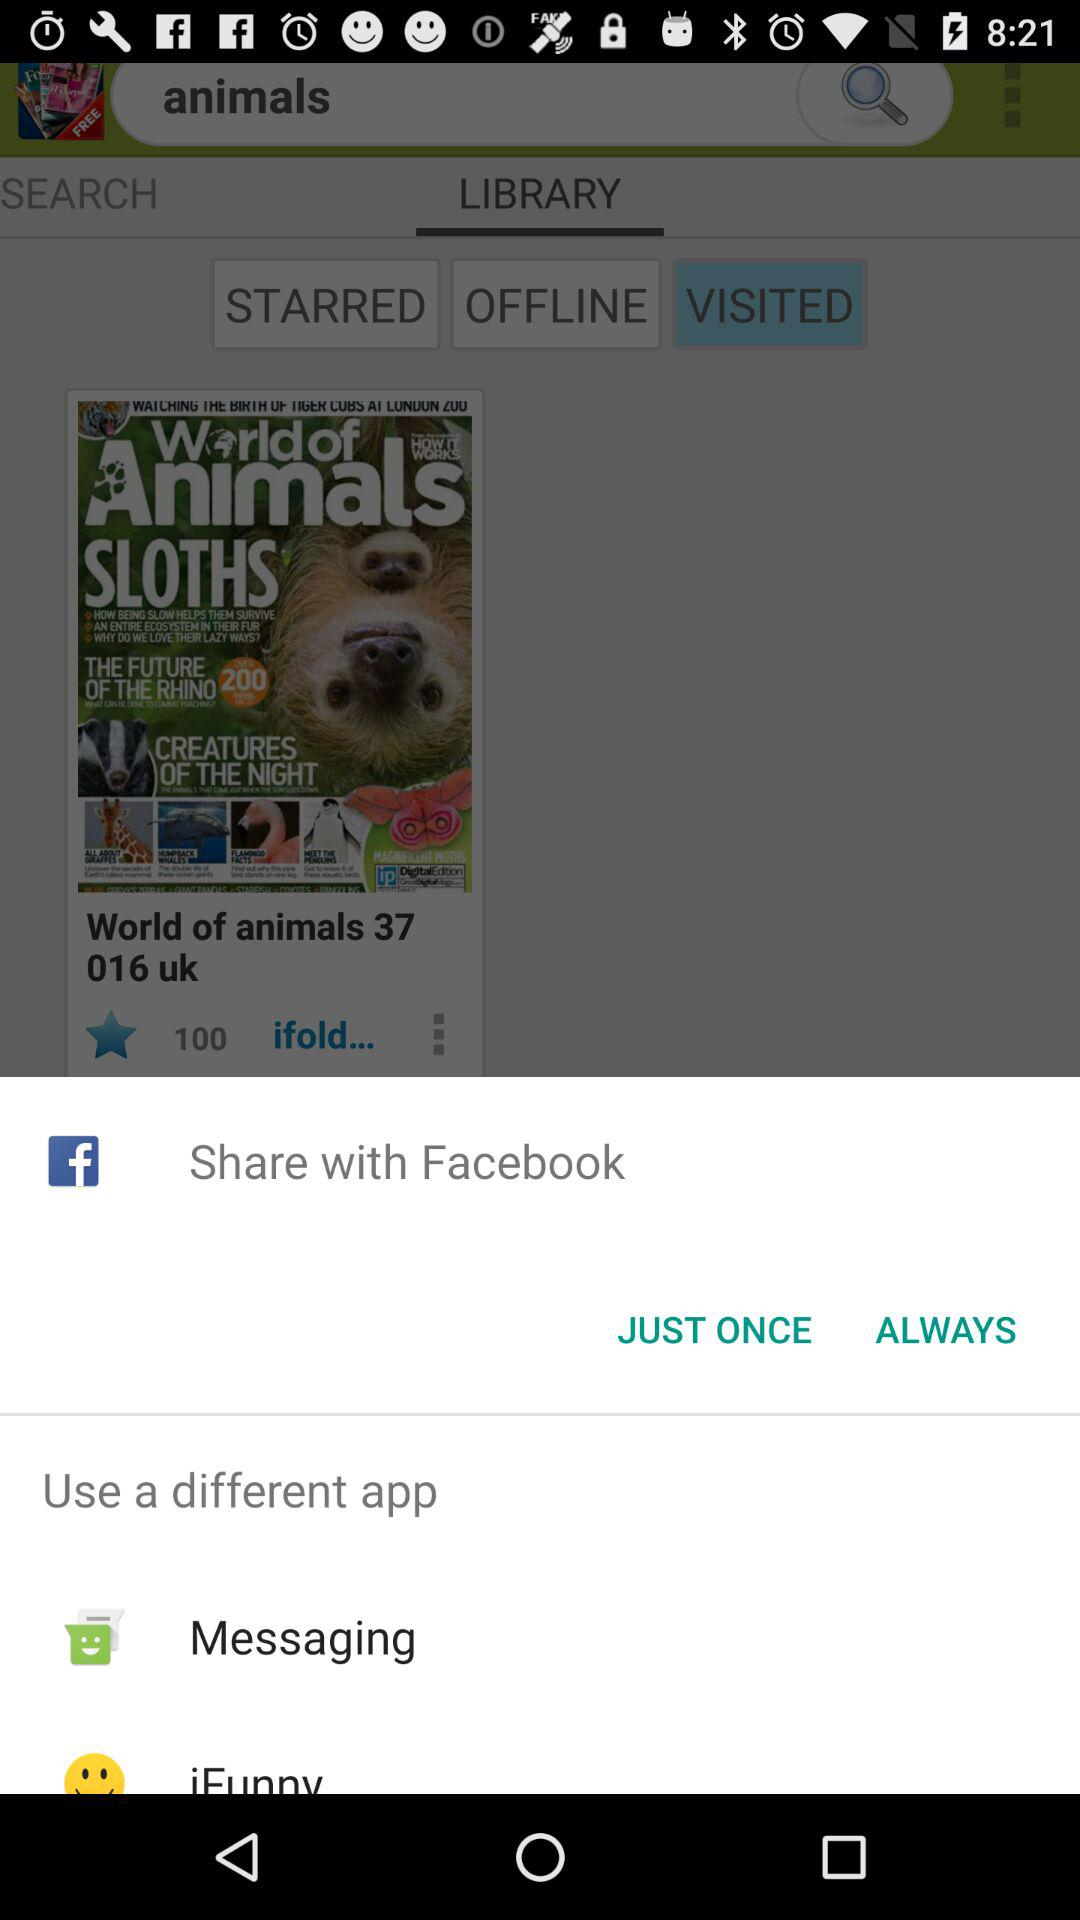What is the option to share? The option to share is "Facebook". 